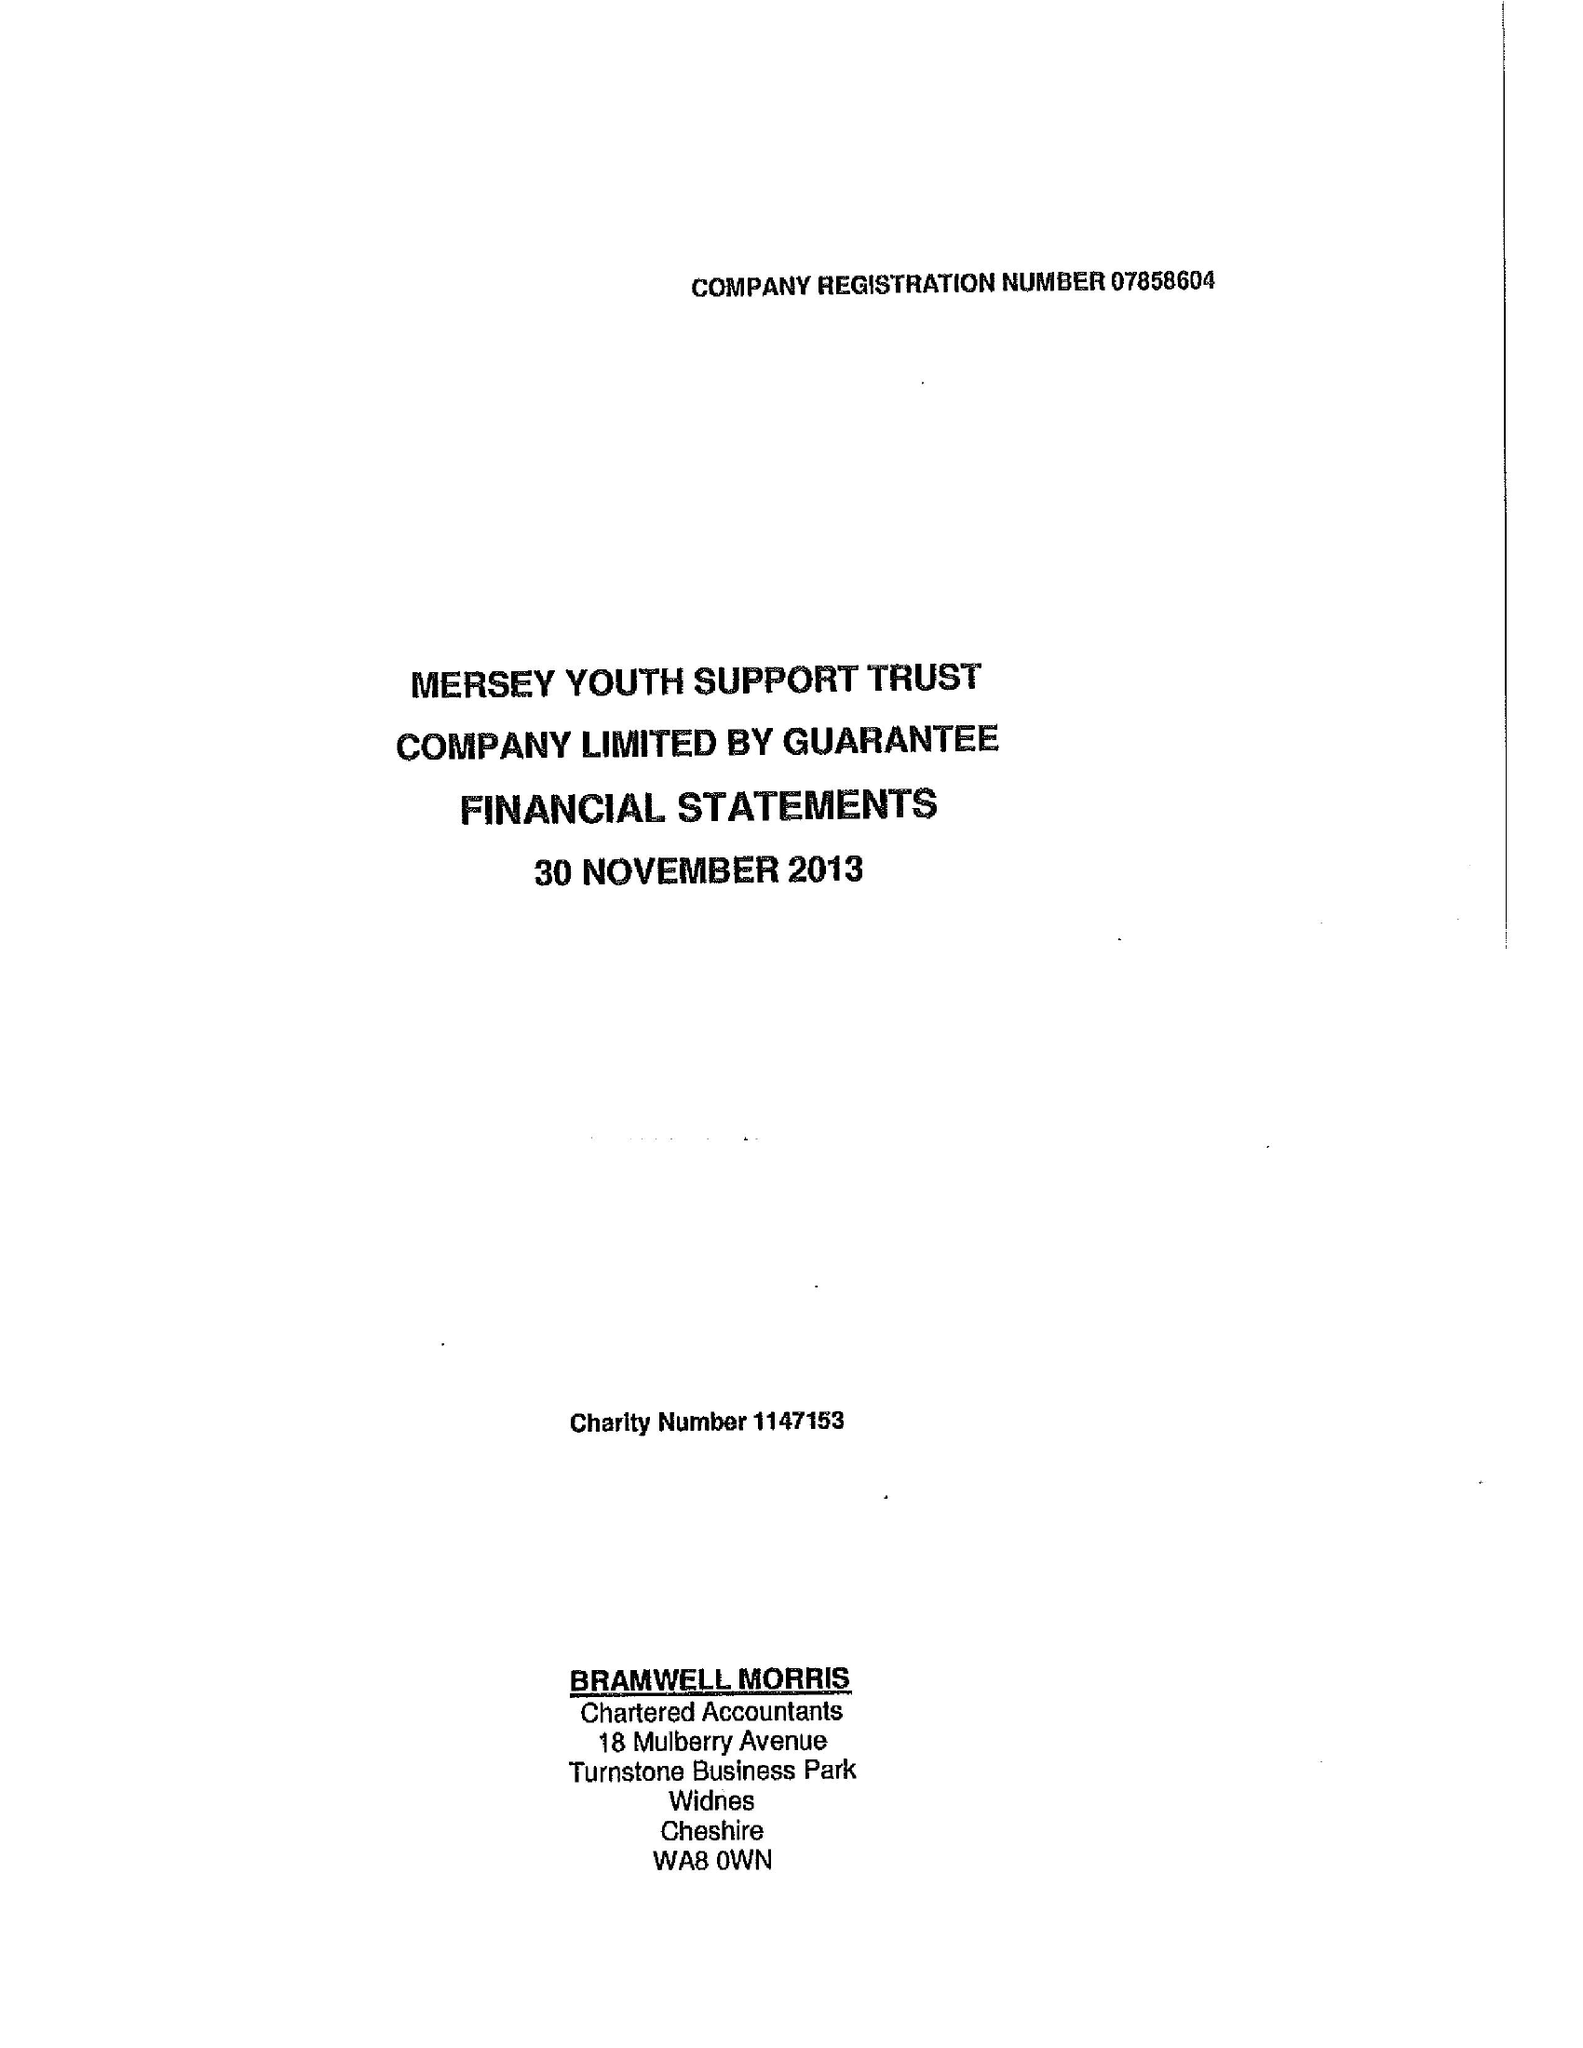What is the value for the report_date?
Answer the question using a single word or phrase. 2013-11-30 